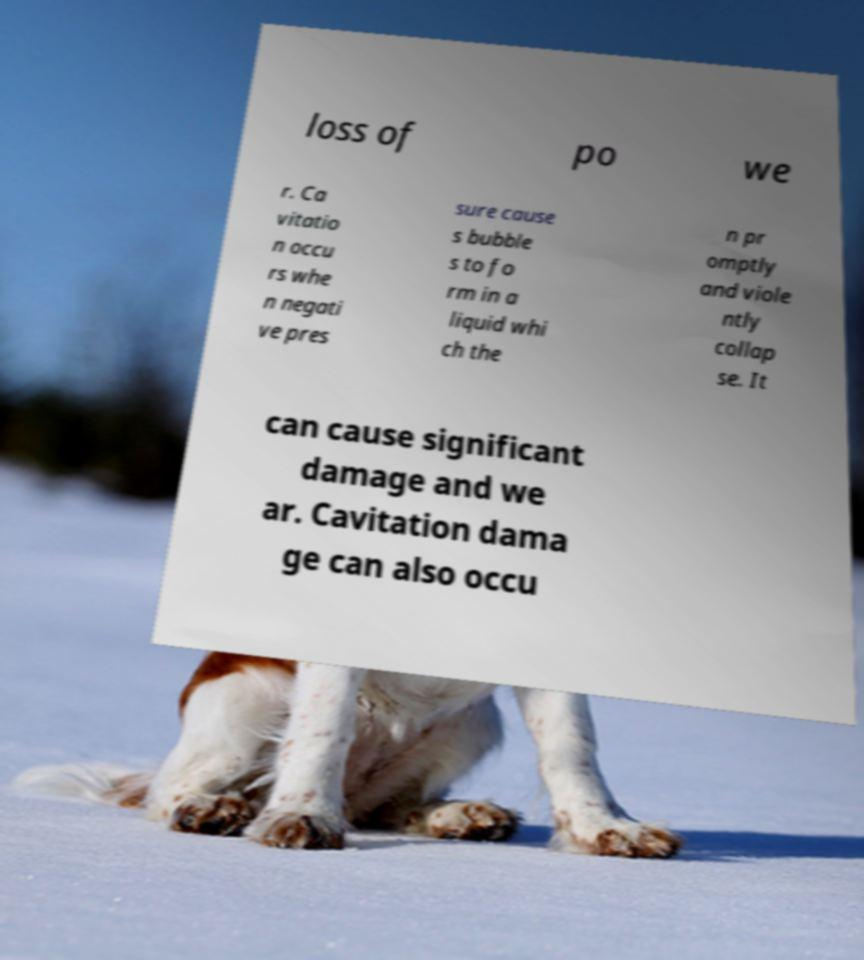Could you extract and type out the text from this image? loss of po we r. Ca vitatio n occu rs whe n negati ve pres sure cause s bubble s to fo rm in a liquid whi ch the n pr omptly and viole ntly collap se. It can cause significant damage and we ar. Cavitation dama ge can also occu 